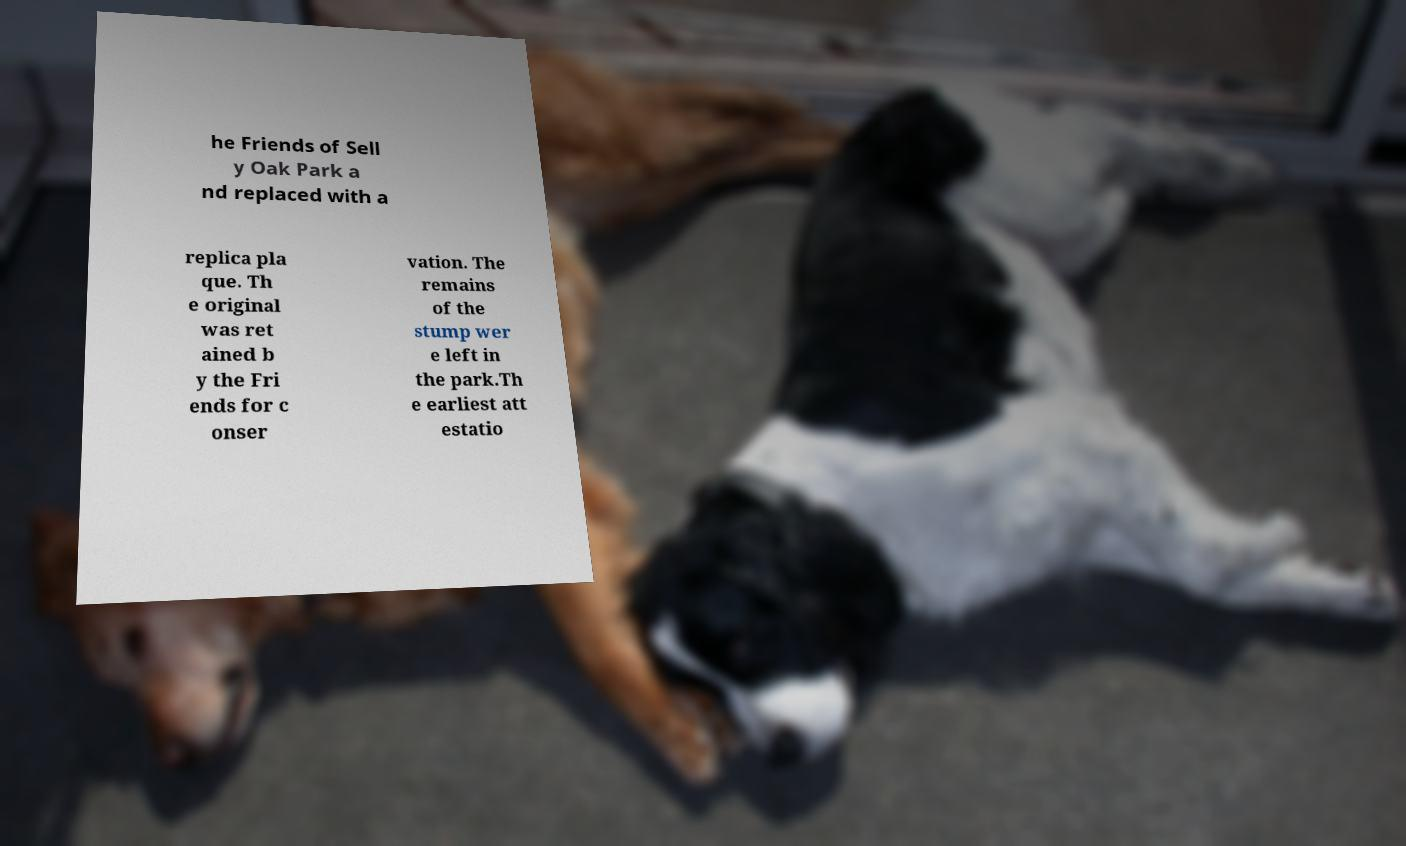Can you accurately transcribe the text from the provided image for me? he Friends of Sell y Oak Park a nd replaced with a replica pla que. Th e original was ret ained b y the Fri ends for c onser vation. The remains of the stump wer e left in the park.Th e earliest att estatio 